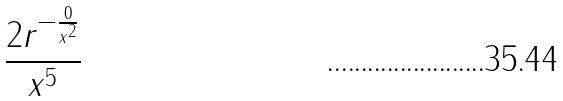Convert formula to latex. <formula><loc_0><loc_0><loc_500><loc_500>\frac { 2 r ^ { - \frac { 0 } { x ^ { 2 } } } } { x ^ { 5 } }</formula> 